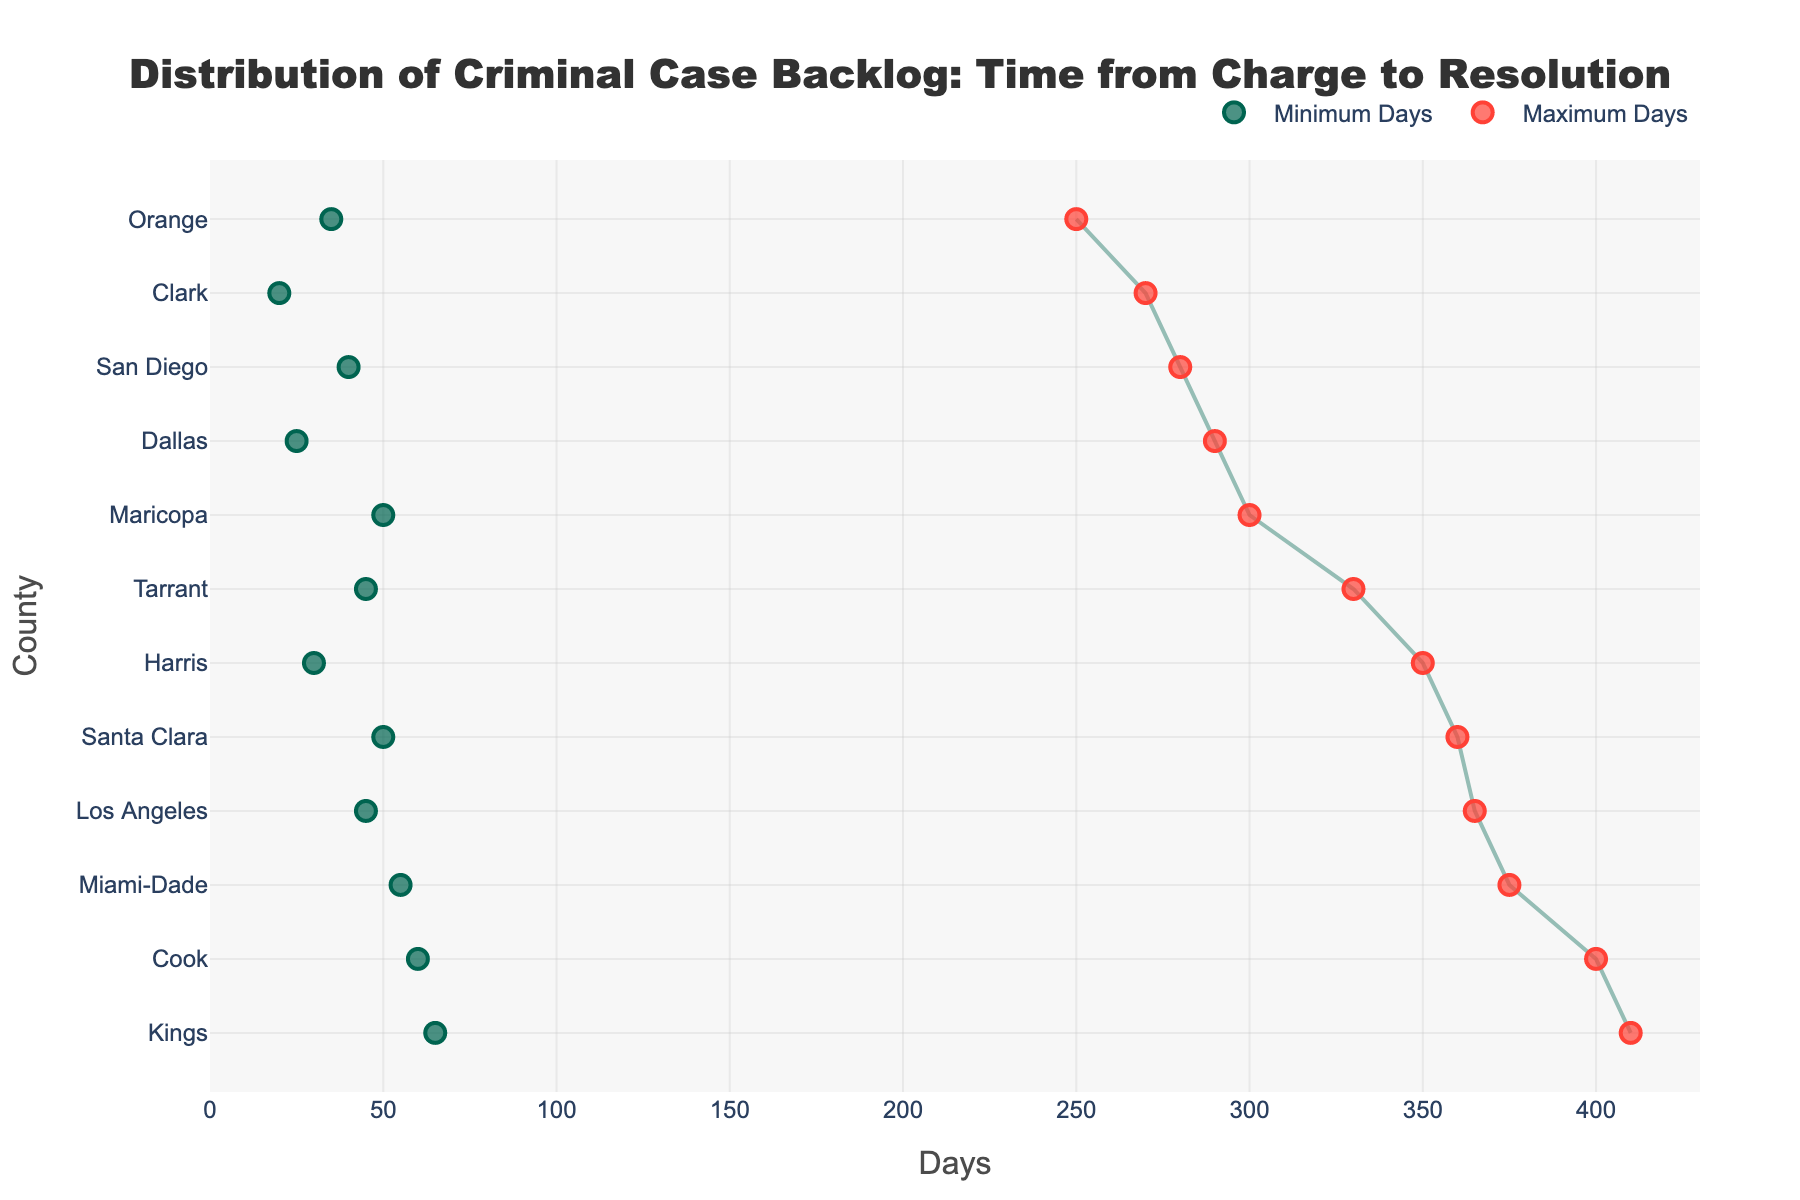Which county has the longest maximum days for resolving criminal cases? From the figure, locate the county with the highest value on the x-axis marked with a red circle. Kings County has the longest maximum days, 410.
Answer: Kings What is the minimum number of days to resolve cases in Clark County? Find the green circle corresponding to Clark County on the y-axis. The value is 20 days.
Answer: 20 How does the case resolution range in Harris County compare to Dallas County? Check both counties' positions on the y-axis. Harris County ranges from 30 to 350 days, while Dallas County ranges from 25 to 290 days. Harris County has a broader range.
Answer: Broader What is the average range of case resolution time in Los Angeles? Find the minimum and maximum values for Los Angeles (45 and 365). Calculate the average of these values: (45 + 365) / 2 = 205.
Answer: 205 Which county has the shortest minimum days for resolving criminal cases? Look for the marker with the lowest value on the x-axis for the green circles. Clark County has the shortest minimum days, 20.
Answer: Clark Is the maximum resolution time for cases in Cook County greater than in Maricopa County? Compare the red circles for both counties. Cook County has a maximum of 400 days, while Maricopa County has 300 days. Yes, Cook County's maximum is greater.
Answer: Yes Which counties have a maximum resolution time of more than 350 days? Identify the counties with red circles exceeding the 350-day mark on the x-axis. Los Angeles, Cook, Miami-Dade, Kings, and Santa Clara have maximum days over 350.
Answer: Los Angeles, Cook, Miami-Dade, Kings, Santa Clara What is the difference between the maximum and minimum days for resolving cases in Tarrant County? For Tarrant County, note the values 45 and 330. The difference is 330 - 45 = 285 days.
Answer: 285 Which county has the narrowest range of days for resolving cases? Compare the difference between the maximum and minimum values for all counties. Orange County has the smallest range with 250 - 35 = 215 days.
Answer: Orange 